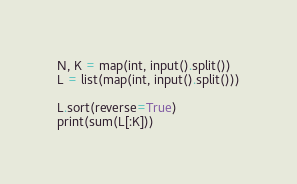<code> <loc_0><loc_0><loc_500><loc_500><_Python_>N, K = map(int, input().split())
L = list(map(int, input().split()))

L.sort(reverse=True)
print(sum(L[:K]))</code> 